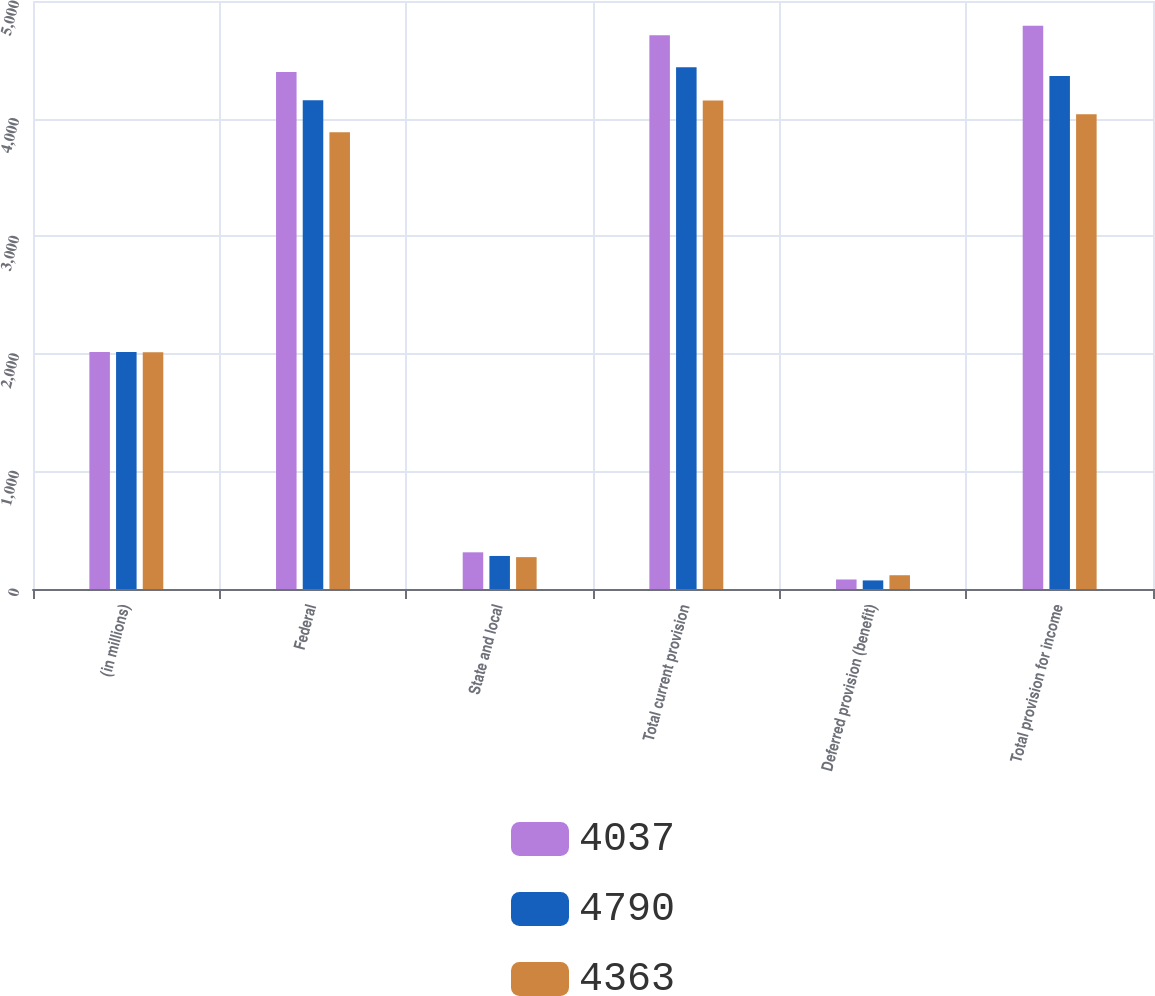Convert chart to OTSL. <chart><loc_0><loc_0><loc_500><loc_500><stacked_bar_chart><ecel><fcel>(in millions)<fcel>Federal<fcel>State and local<fcel>Total current provision<fcel>Deferred provision (benefit)<fcel>Total provision for income<nl><fcel>4037<fcel>2016<fcel>4397<fcel>312<fcel>4709<fcel>81<fcel>4790<nl><fcel>4790<fcel>2015<fcel>4155<fcel>281<fcel>4436<fcel>73<fcel>4363<nl><fcel>4363<fcel>2014<fcel>3883<fcel>271<fcel>4154<fcel>117<fcel>4037<nl></chart> 